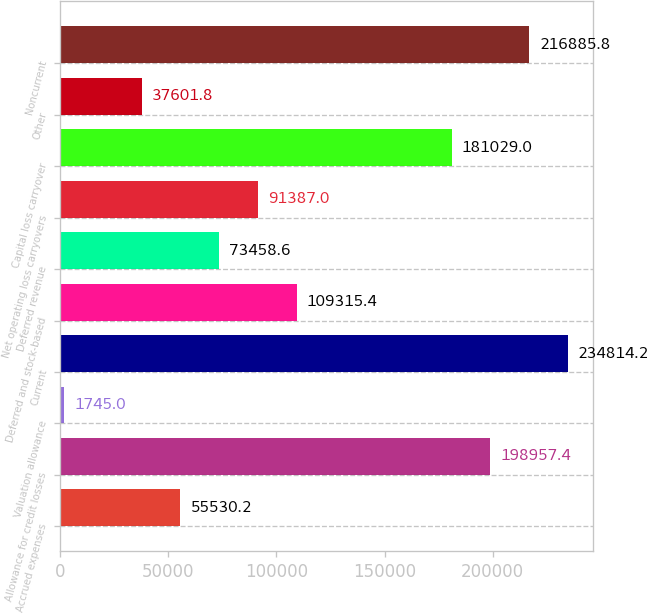Convert chart to OTSL. <chart><loc_0><loc_0><loc_500><loc_500><bar_chart><fcel>Accrued expenses<fcel>Allowance for credit losses<fcel>Valuation allowance<fcel>Current<fcel>Deferred and stock-based<fcel>Deferred revenue<fcel>Net operating loss carryovers<fcel>Capital loss carryover<fcel>Other<fcel>Noncurrent<nl><fcel>55530.2<fcel>198957<fcel>1745<fcel>234814<fcel>109315<fcel>73458.6<fcel>91387<fcel>181029<fcel>37601.8<fcel>216886<nl></chart> 